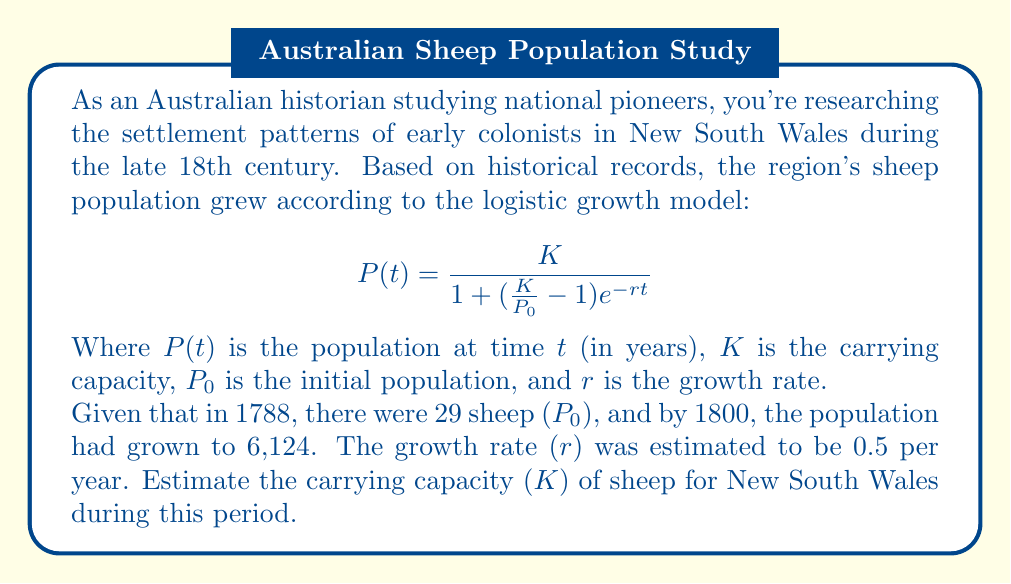Can you solve this math problem? To solve this problem, we'll use the logistic growth model equation and the given information to estimate the carrying capacity (K) for sheep in New South Wales.

Given:
- Initial population (P_0) = 29 sheep in 1788
- Population (P(t)) = 6,124 sheep in 1800
- Growth rate (r) = 0.5 per year
- Time period (t) = 12 years (1800 - 1788)

Step 1: Substitute the known values into the logistic growth equation:

$$6,124 = \frac{K}{1 + (\frac{K}{29} - 1)e^{-0.5 \cdot 12}}$$

Step 2: Simplify the exponent:

$$6,124 = \frac{K}{1 + (\frac{K}{29} - 1)e^{-6}}$$

Step 3: Let $a = e^{-6}$ to simplify the equation:

$$6,124 = \frac{K}{1 + (\frac{K}{29} - 1)a}$$

Step 4: Cross-multiply to eliminate the fraction:

$$6,124 + 6,124(\frac{K}{29} - 1)a = K$$

Step 5: Expand the equation:

$$6,124 + \frac{6,124K}{29}a - 6,124a = K$$

Step 6: Rearrange the equation to group K terms:

$$K - \frac{6,124K}{29}a = 6,124 - 6,124a$$

Step 7: Factor out K:

$$K(1 - \frac{6,124}{29}a) = 6,124(1 - a)$$

Step 8: Solve for K:

$$K = \frac{6,124(1 - a)}{1 - \frac{6,124}{29}a}$$

Step 9: Calculate the value of a:

$$a = e^{-6} \approx 0.00248$$

Step 10: Substitute the value of a and calculate K:

$$K = \frac{6,124(1 - 0.00248)}{1 - \frac{6,124}{29} \cdot 0.00248} \approx 6,165$$

Therefore, the estimated carrying capacity (K) for sheep in New South Wales during this period is approximately 6,165 sheep.
Answer: The estimated carrying capacity (K) for sheep in New South Wales during the late 18th century is approximately 6,165 sheep. 